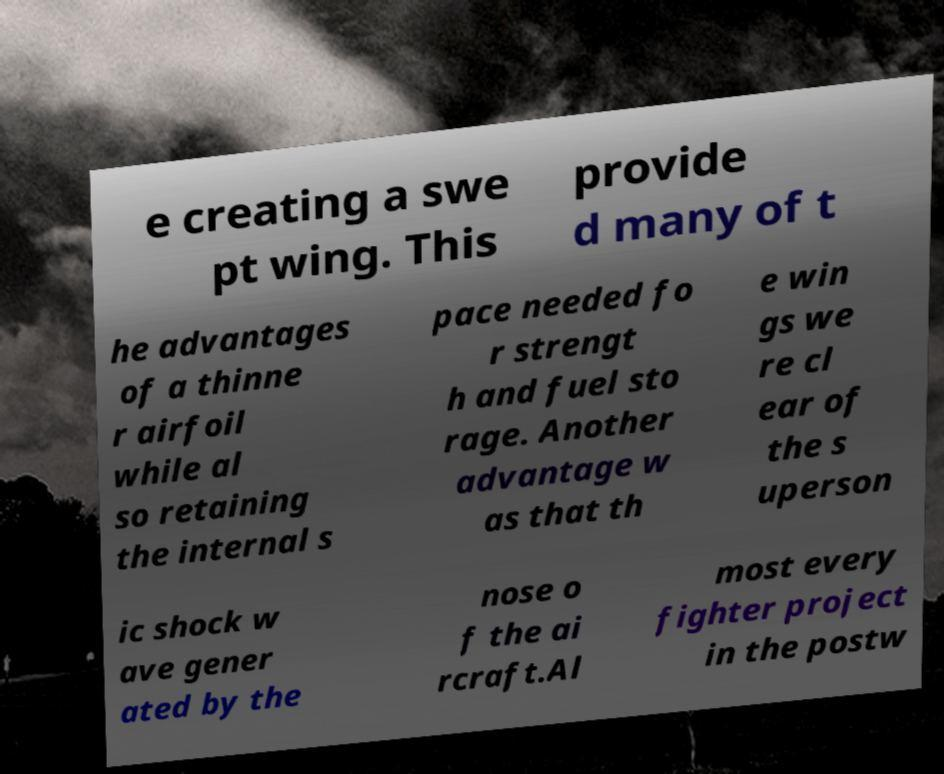Could you extract and type out the text from this image? e creating a swe pt wing. This provide d many of t he advantages of a thinne r airfoil while al so retaining the internal s pace needed fo r strengt h and fuel sto rage. Another advantage w as that th e win gs we re cl ear of the s uperson ic shock w ave gener ated by the nose o f the ai rcraft.Al most every fighter project in the postw 